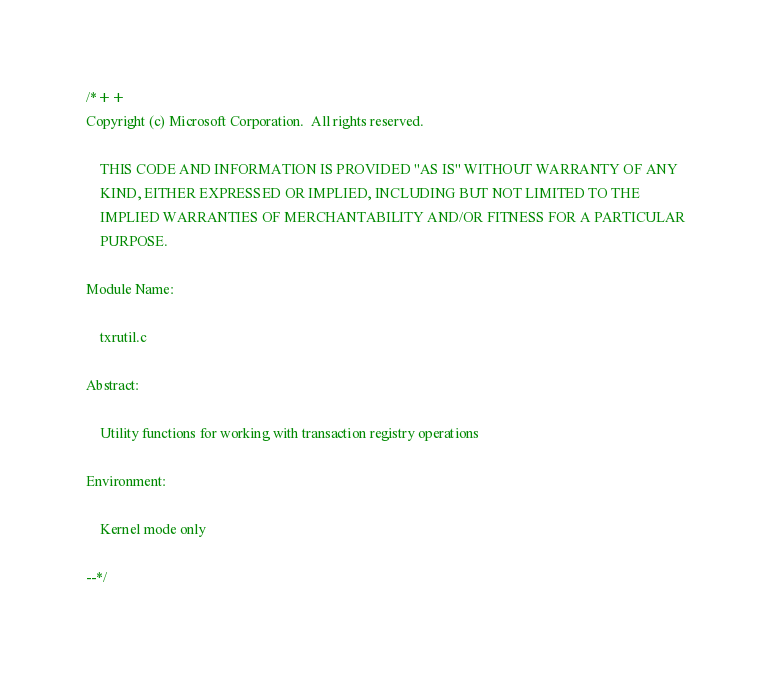Convert code to text. <code><loc_0><loc_0><loc_500><loc_500><_C_>/*++
Copyright (c) Microsoft Corporation.  All rights reserved.

    THIS CODE AND INFORMATION IS PROVIDED "AS IS" WITHOUT WARRANTY OF ANY
    KIND, EITHER EXPRESSED OR IMPLIED, INCLUDING BUT NOT LIMITED TO THE
    IMPLIED WARRANTIES OF MERCHANTABILITY AND/OR FITNESS FOR A PARTICULAR
    PURPOSE.

Module Name:

    txrutil.c

Abstract: 

    Utility functions for working with transaction registry operations

Environment:

    Kernel mode only

--*/
</code> 